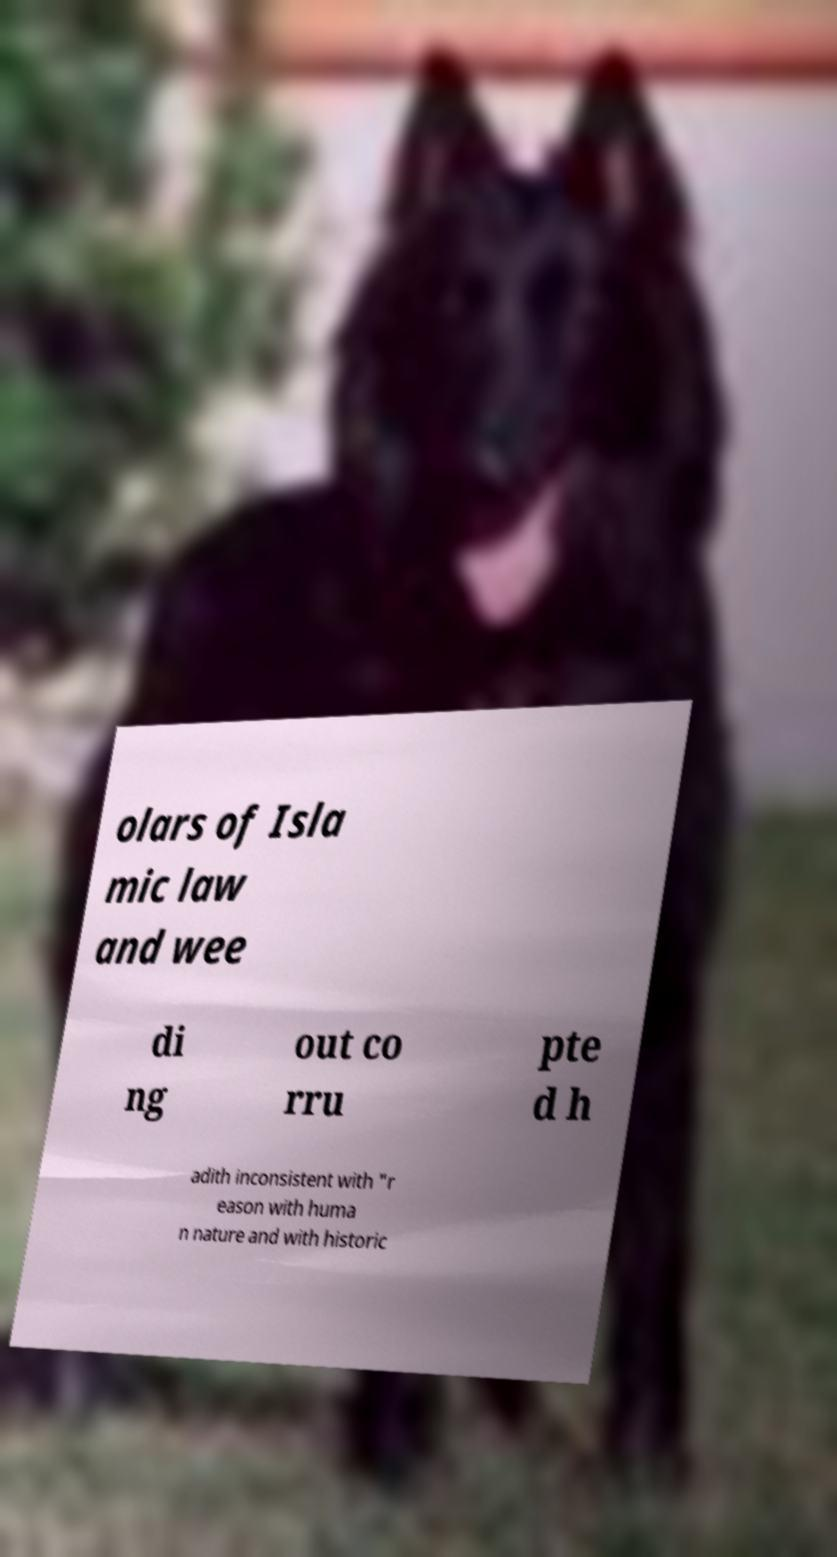Please identify and transcribe the text found in this image. olars of Isla mic law and wee di ng out co rru pte d h adith inconsistent with "r eason with huma n nature and with historic 